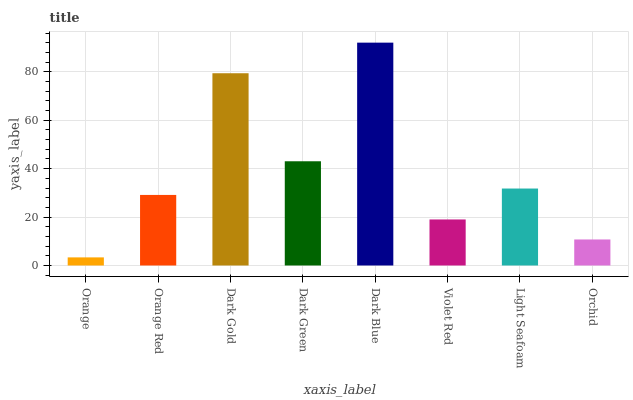Is Orange the minimum?
Answer yes or no. Yes. Is Dark Blue the maximum?
Answer yes or no. Yes. Is Orange Red the minimum?
Answer yes or no. No. Is Orange Red the maximum?
Answer yes or no. No. Is Orange Red greater than Orange?
Answer yes or no. Yes. Is Orange less than Orange Red?
Answer yes or no. Yes. Is Orange greater than Orange Red?
Answer yes or no. No. Is Orange Red less than Orange?
Answer yes or no. No. Is Light Seafoam the high median?
Answer yes or no. Yes. Is Orange Red the low median?
Answer yes or no. Yes. Is Orange the high median?
Answer yes or no. No. Is Dark Green the low median?
Answer yes or no. No. 